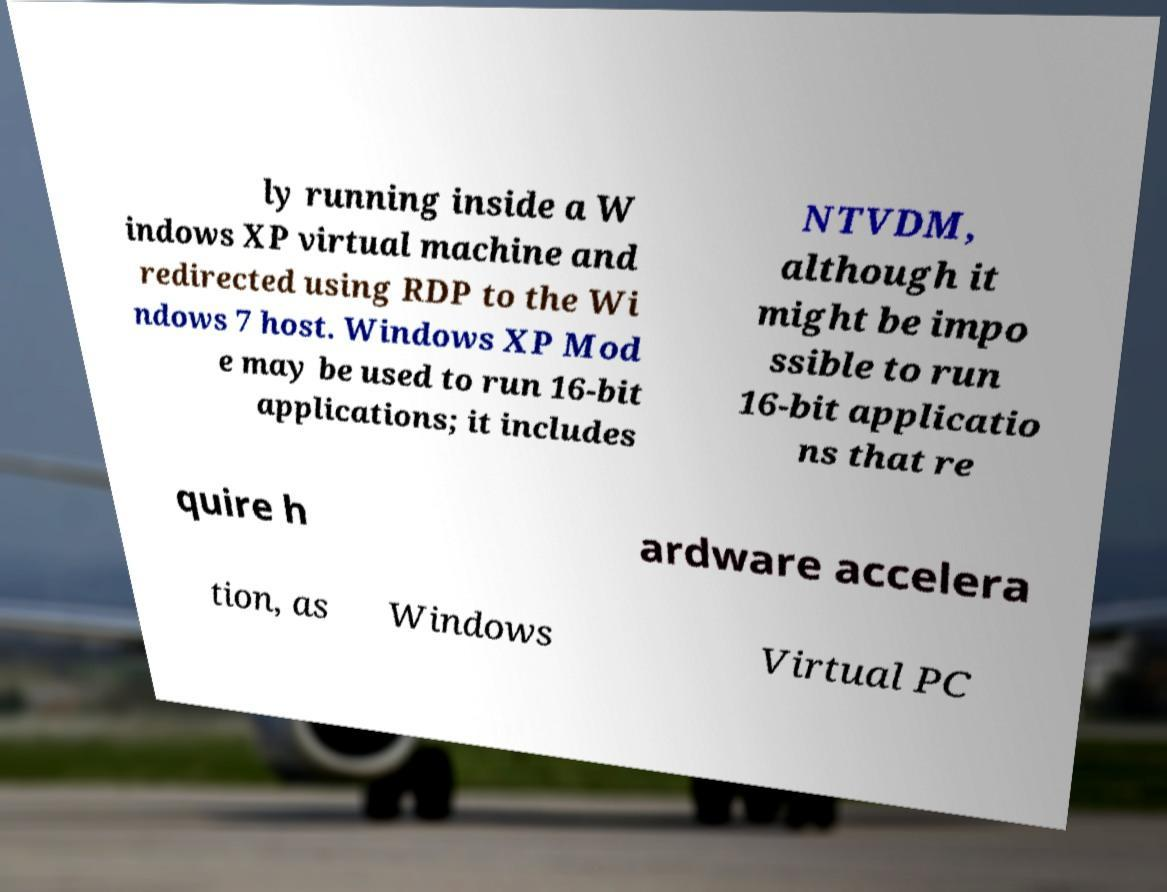I need the written content from this picture converted into text. Can you do that? ly running inside a W indows XP virtual machine and redirected using RDP to the Wi ndows 7 host. Windows XP Mod e may be used to run 16-bit applications; it includes NTVDM, although it might be impo ssible to run 16-bit applicatio ns that re quire h ardware accelera tion, as Windows Virtual PC 